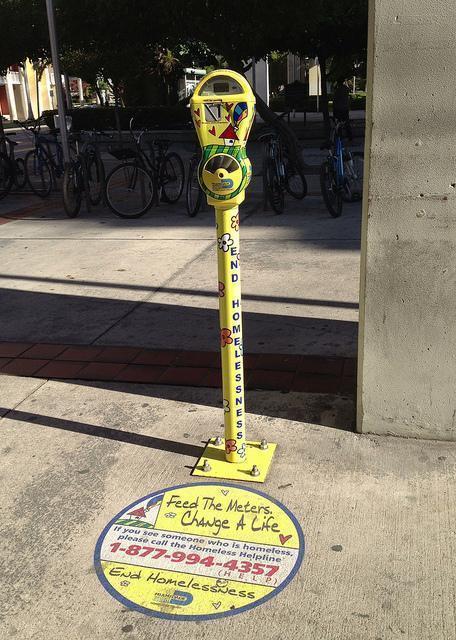What are they hoping to collect?
Indicate the correct response and explain using: 'Answer: answer
Rationale: rationale.'
Options: Coins, points, ideas, signatures. Answer: coins.
Rationale: The machine has a slot for inserting coins. 